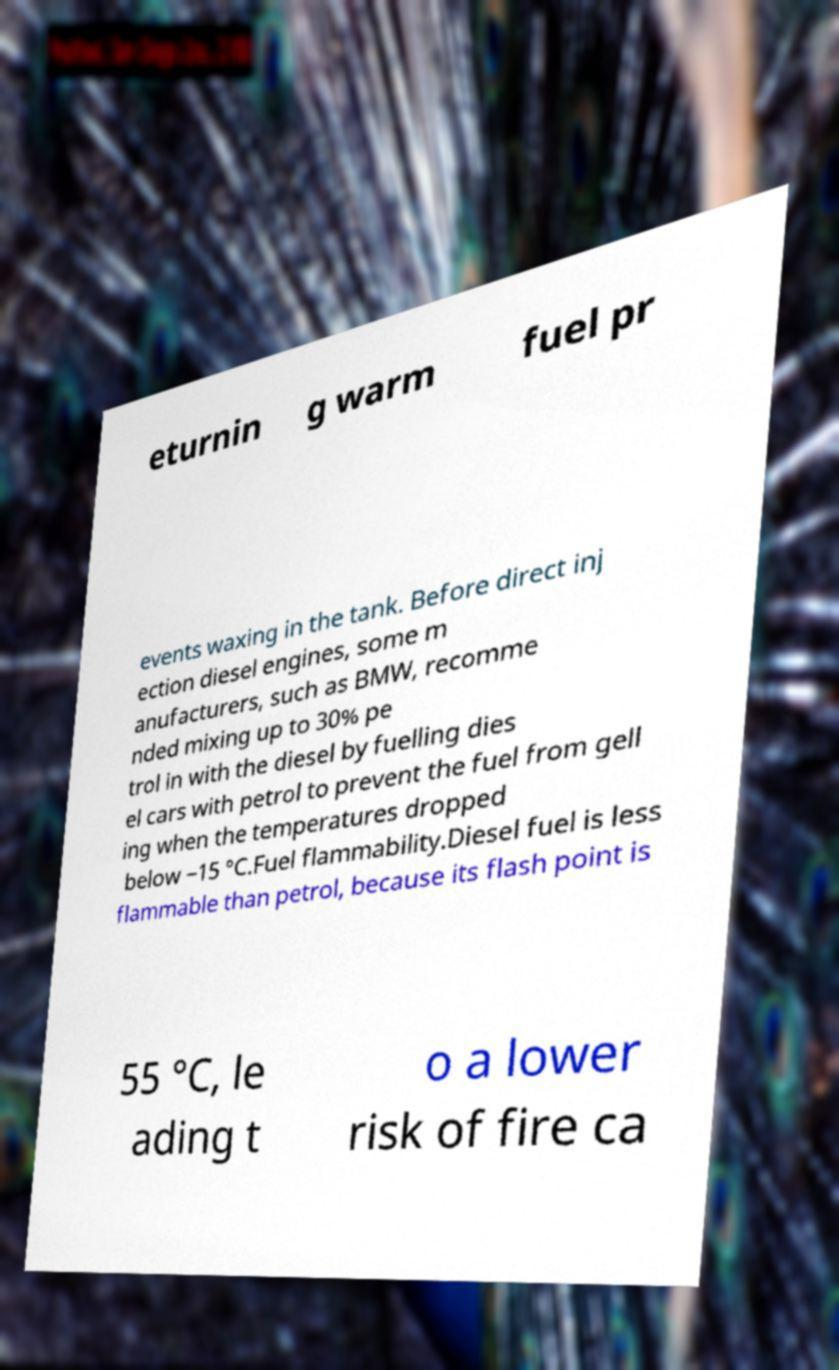Please identify and transcribe the text found in this image. eturnin g warm fuel pr events waxing in the tank. Before direct inj ection diesel engines, some m anufacturers, such as BMW, recomme nded mixing up to 30% pe trol in with the diesel by fuelling dies el cars with petrol to prevent the fuel from gell ing when the temperatures dropped below −15 °C.Fuel flammability.Diesel fuel is less flammable than petrol, because its flash point is 55 °C, le ading t o a lower risk of fire ca 